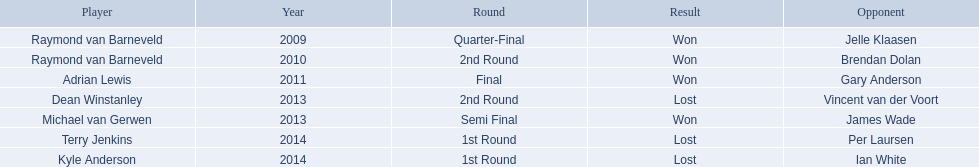What was the names of all the players? Raymond van Barneveld, Raymond van Barneveld, Adrian Lewis, Dean Winstanley, Michael van Gerwen, Terry Jenkins, Kyle Anderson. What years were the championship offered? 2009, 2010, 2011, 2013, 2013, 2014, 2014. Of these, who played in 2011? Adrian Lewis. What are all the years available? 2009, 2010, 2011, 2013, 2013, 2014, 2014. Among them, which ones correspond to 2014? 2014, 2014. From these dates, which one is related to a player other than kyle anderson? 2014. What is the name of the player connected to this year? Terry Jenkins. 